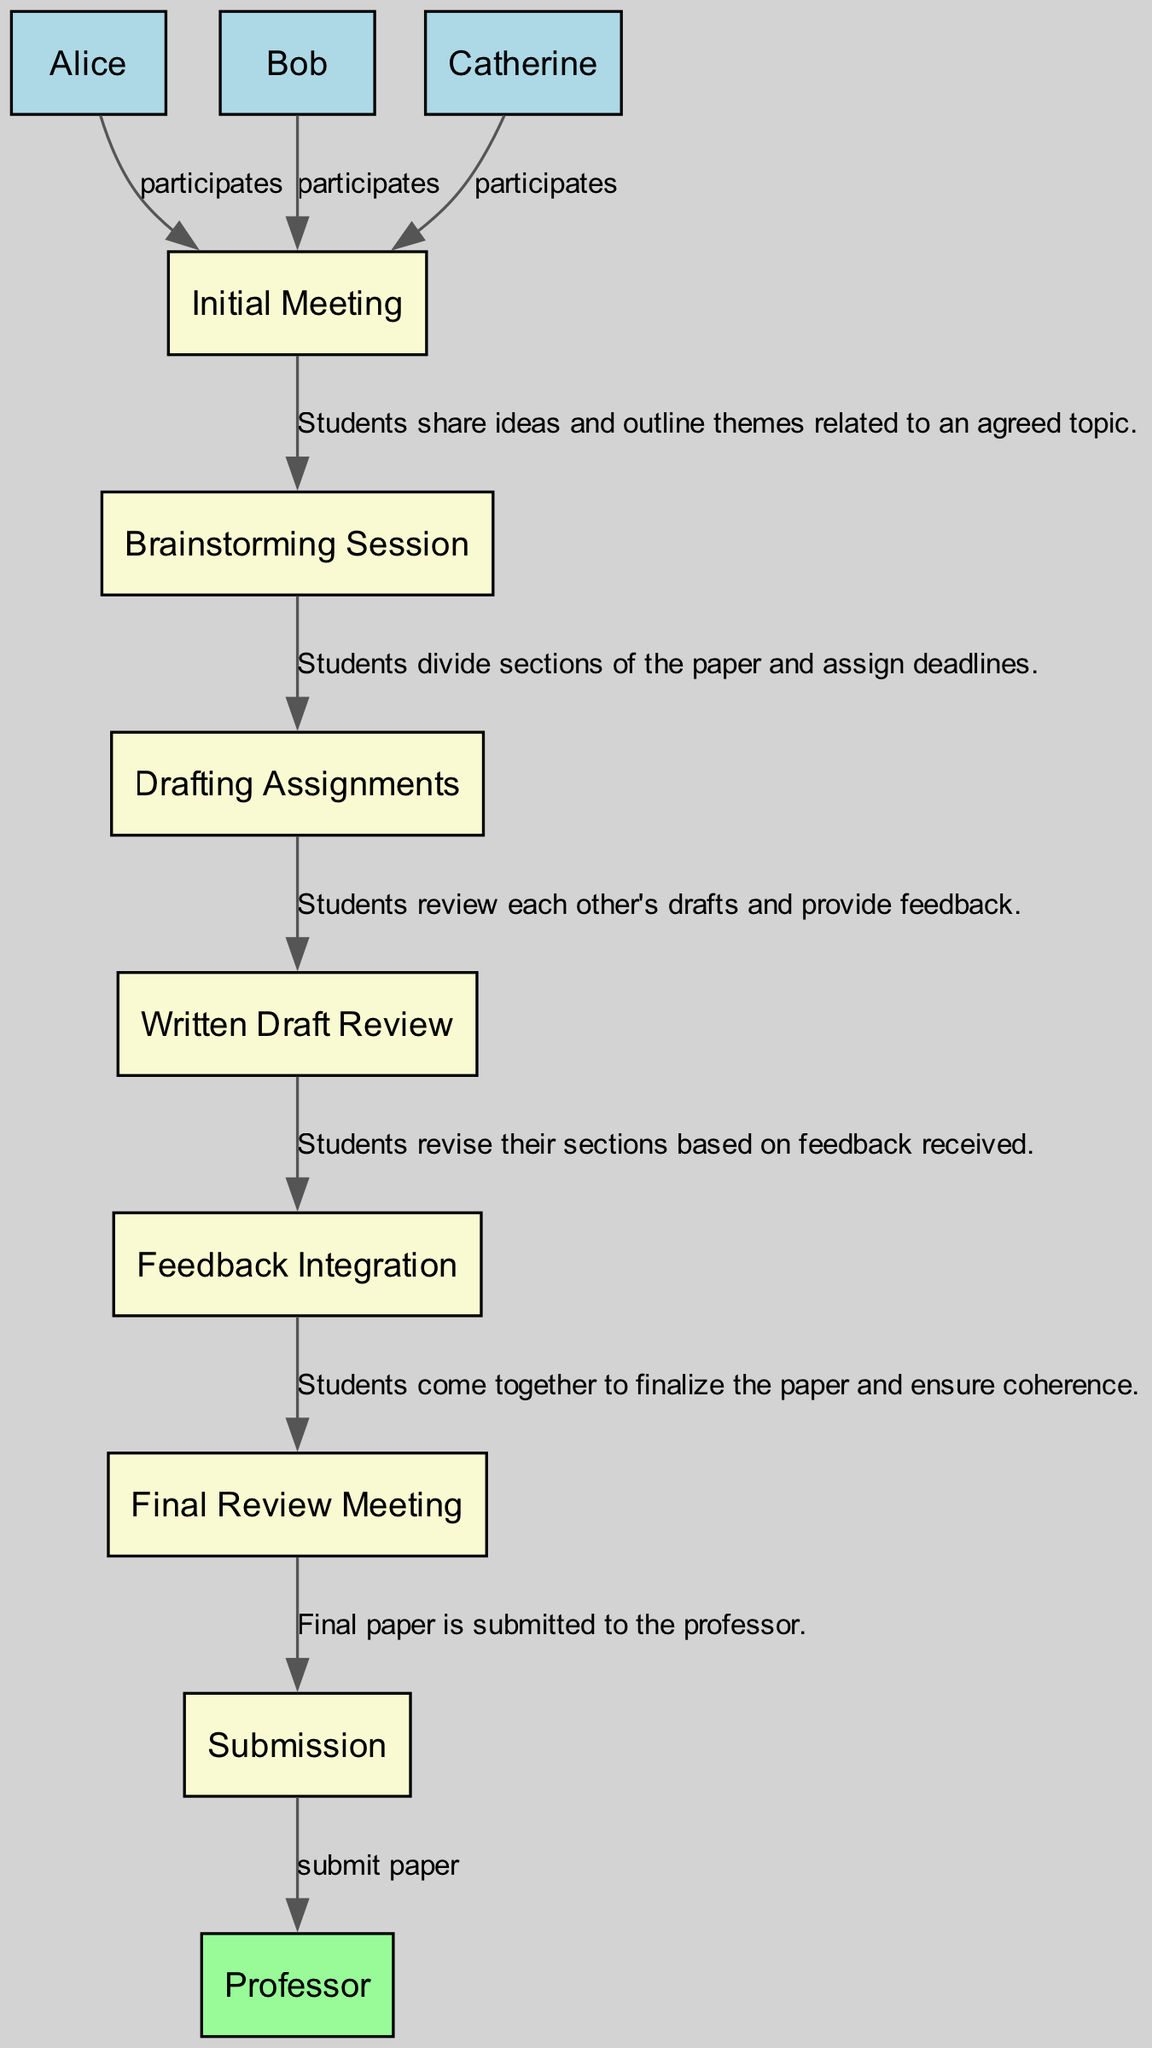What is the first step in the collaboration process? The diagram outlines the collaboration process starting with the "Initial Meeting," where the students gather to discuss potential topics.
Answer: Initial Meeting How many philosophy students are involved in the process? The diagram lists three students: Alice, Bob, and Catherine, indicating that a total of three students are participating in the collaboration.
Answer: 3 What is the last step before submitting the paper? Before submission, the final step is the "Final Review Meeting," which involves ensuring coherence and finalizing the paper among the students.
Answer: Final Review Meeting Which student participates in all steps? Each philosophy student, Alice, Bob, and Catherine, participates in all steps as indicated by the connections from each student's box to each process step in the diagram.
Answer: All students What type of relationship exists between students and the steps? The relationship is that all students are involved in each collaboration step, participating actively in the process from the initial meeting through to submission.
Answer: Participates Which step involves providing feedback on drafts? The step specifically aimed at reviewing drafts and giving feedback is titled "Written Draft Review," where students evaluate each other’s drafts.
Answer: Written Draft Review How many edges connect the steps of the collaboration process? The collaboration process has six edges connecting each of the seven steps of the process (from "Initial Meeting" to "Submission") that show the flow of activities.
Answer: 6 During which step do students integrate feedback? Students integrate feedback during the "Feedback Integration" step, where they revise their sections based on the feedback received from each other.
Answer: Feedback Integration Who do the students submit the final paper to? The final paper is submitted to "Professor," who is represented in the diagram and is the recipient of the completed work.
Answer: Professor 